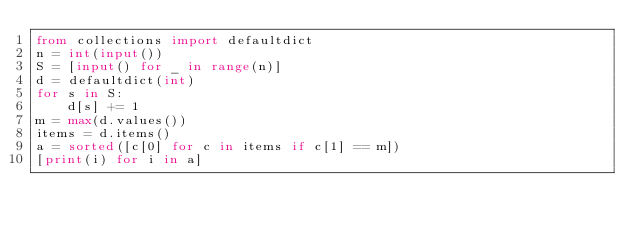<code> <loc_0><loc_0><loc_500><loc_500><_Python_>from collections import defaultdict
n = int(input())
S = [input() for _ in range(n)]
d = defaultdict(int)
for s in S:
    d[s] += 1
m = max(d.values())
items = d.items()
a = sorted([c[0] for c in items if c[1] == m])
[print(i) for i in a]
</code> 